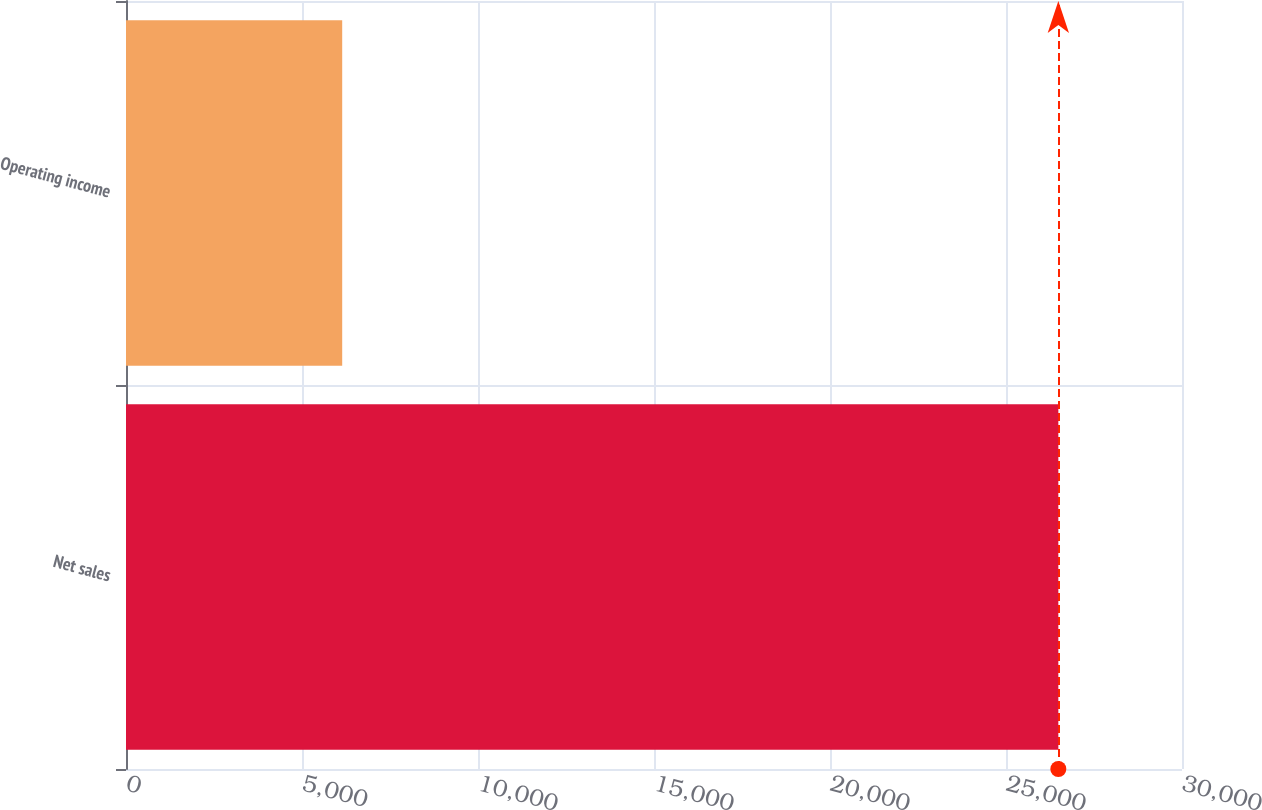Convert chart to OTSL. <chart><loc_0><loc_0><loc_500><loc_500><bar_chart><fcel>Net sales<fcel>Operating income<nl><fcel>26487<fcel>6142<nl></chart> 